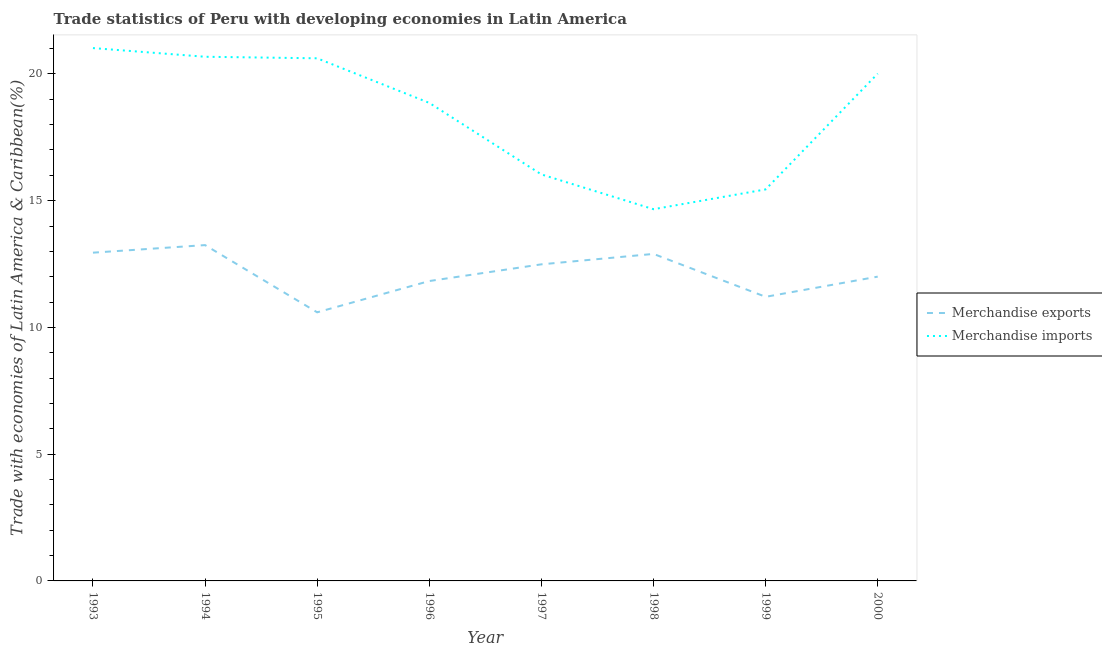Is the number of lines equal to the number of legend labels?
Provide a short and direct response. Yes. What is the merchandise imports in 2000?
Offer a terse response. 20.01. Across all years, what is the maximum merchandise imports?
Your response must be concise. 21.02. Across all years, what is the minimum merchandise imports?
Your response must be concise. 14.66. In which year was the merchandise imports maximum?
Ensure brevity in your answer.  1993. In which year was the merchandise exports minimum?
Give a very brief answer. 1995. What is the total merchandise exports in the graph?
Give a very brief answer. 97.23. What is the difference between the merchandise exports in 1996 and that in 1998?
Provide a short and direct response. -1.07. What is the difference between the merchandise imports in 1997 and the merchandise exports in 1994?
Your answer should be very brief. 2.79. What is the average merchandise imports per year?
Give a very brief answer. 18.42. In the year 1995, what is the difference between the merchandise imports and merchandise exports?
Make the answer very short. 10.02. What is the ratio of the merchandise exports in 1993 to that in 1998?
Provide a succinct answer. 1. Is the merchandise exports in 1997 less than that in 1999?
Your answer should be compact. No. Is the difference between the merchandise exports in 1994 and 1998 greater than the difference between the merchandise imports in 1994 and 1998?
Give a very brief answer. No. What is the difference between the highest and the second highest merchandise imports?
Provide a succinct answer. 0.34. What is the difference between the highest and the lowest merchandise imports?
Your answer should be very brief. 6.36. Is the sum of the merchandise imports in 1995 and 1999 greater than the maximum merchandise exports across all years?
Offer a very short reply. Yes. Does the merchandise exports monotonically increase over the years?
Your answer should be compact. No. Is the merchandise imports strictly greater than the merchandise exports over the years?
Ensure brevity in your answer.  Yes. How many lines are there?
Ensure brevity in your answer.  2. How many years are there in the graph?
Your answer should be compact. 8. What is the difference between two consecutive major ticks on the Y-axis?
Provide a succinct answer. 5. Are the values on the major ticks of Y-axis written in scientific E-notation?
Keep it short and to the point. No. Does the graph contain any zero values?
Give a very brief answer. No. Where does the legend appear in the graph?
Provide a short and direct response. Center right. How many legend labels are there?
Your response must be concise. 2. How are the legend labels stacked?
Your response must be concise. Vertical. What is the title of the graph?
Make the answer very short. Trade statistics of Peru with developing economies in Latin America. Does "Canada" appear as one of the legend labels in the graph?
Offer a very short reply. No. What is the label or title of the Y-axis?
Ensure brevity in your answer.  Trade with economies of Latin America & Caribbean(%). What is the Trade with economies of Latin America & Caribbean(%) of Merchandise exports in 1993?
Offer a very short reply. 12.95. What is the Trade with economies of Latin America & Caribbean(%) of Merchandise imports in 1993?
Give a very brief answer. 21.02. What is the Trade with economies of Latin America & Caribbean(%) in Merchandise exports in 1994?
Provide a succinct answer. 13.25. What is the Trade with economies of Latin America & Caribbean(%) of Merchandise imports in 1994?
Your answer should be very brief. 20.68. What is the Trade with economies of Latin America & Caribbean(%) of Merchandise exports in 1995?
Your answer should be very brief. 10.6. What is the Trade with economies of Latin America & Caribbean(%) in Merchandise imports in 1995?
Provide a succinct answer. 20.62. What is the Trade with economies of Latin America & Caribbean(%) of Merchandise exports in 1996?
Give a very brief answer. 11.83. What is the Trade with economies of Latin America & Caribbean(%) of Merchandise imports in 1996?
Ensure brevity in your answer.  18.86. What is the Trade with economies of Latin America & Caribbean(%) of Merchandise exports in 1997?
Keep it short and to the point. 12.49. What is the Trade with economies of Latin America & Caribbean(%) of Merchandise imports in 1997?
Your answer should be very brief. 16.04. What is the Trade with economies of Latin America & Caribbean(%) of Merchandise exports in 1998?
Your answer should be very brief. 12.9. What is the Trade with economies of Latin America & Caribbean(%) of Merchandise imports in 1998?
Ensure brevity in your answer.  14.66. What is the Trade with economies of Latin America & Caribbean(%) of Merchandise exports in 1999?
Your response must be concise. 11.21. What is the Trade with economies of Latin America & Caribbean(%) in Merchandise imports in 1999?
Your response must be concise. 15.45. What is the Trade with economies of Latin America & Caribbean(%) of Merchandise exports in 2000?
Offer a very short reply. 12. What is the Trade with economies of Latin America & Caribbean(%) of Merchandise imports in 2000?
Your response must be concise. 20.01. Across all years, what is the maximum Trade with economies of Latin America & Caribbean(%) of Merchandise exports?
Give a very brief answer. 13.25. Across all years, what is the maximum Trade with economies of Latin America & Caribbean(%) of Merchandise imports?
Provide a succinct answer. 21.02. Across all years, what is the minimum Trade with economies of Latin America & Caribbean(%) in Merchandise exports?
Ensure brevity in your answer.  10.6. Across all years, what is the minimum Trade with economies of Latin America & Caribbean(%) in Merchandise imports?
Give a very brief answer. 14.66. What is the total Trade with economies of Latin America & Caribbean(%) of Merchandise exports in the graph?
Make the answer very short. 97.23. What is the total Trade with economies of Latin America & Caribbean(%) in Merchandise imports in the graph?
Your answer should be very brief. 147.33. What is the difference between the Trade with economies of Latin America & Caribbean(%) in Merchandise exports in 1993 and that in 1994?
Your answer should be compact. -0.3. What is the difference between the Trade with economies of Latin America & Caribbean(%) of Merchandise imports in 1993 and that in 1994?
Offer a terse response. 0.34. What is the difference between the Trade with economies of Latin America & Caribbean(%) in Merchandise exports in 1993 and that in 1995?
Your answer should be very brief. 2.35. What is the difference between the Trade with economies of Latin America & Caribbean(%) in Merchandise imports in 1993 and that in 1995?
Make the answer very short. 0.4. What is the difference between the Trade with economies of Latin America & Caribbean(%) of Merchandise exports in 1993 and that in 1996?
Your answer should be compact. 1.12. What is the difference between the Trade with economies of Latin America & Caribbean(%) in Merchandise imports in 1993 and that in 1996?
Ensure brevity in your answer.  2.16. What is the difference between the Trade with economies of Latin America & Caribbean(%) in Merchandise exports in 1993 and that in 1997?
Ensure brevity in your answer.  0.46. What is the difference between the Trade with economies of Latin America & Caribbean(%) in Merchandise imports in 1993 and that in 1997?
Offer a terse response. 4.98. What is the difference between the Trade with economies of Latin America & Caribbean(%) in Merchandise exports in 1993 and that in 1998?
Offer a terse response. 0.05. What is the difference between the Trade with economies of Latin America & Caribbean(%) in Merchandise imports in 1993 and that in 1998?
Offer a very short reply. 6.36. What is the difference between the Trade with economies of Latin America & Caribbean(%) in Merchandise exports in 1993 and that in 1999?
Provide a succinct answer. 1.74. What is the difference between the Trade with economies of Latin America & Caribbean(%) of Merchandise imports in 1993 and that in 1999?
Ensure brevity in your answer.  5.58. What is the difference between the Trade with economies of Latin America & Caribbean(%) in Merchandise exports in 1993 and that in 2000?
Your answer should be very brief. 0.95. What is the difference between the Trade with economies of Latin America & Caribbean(%) in Merchandise exports in 1994 and that in 1995?
Your answer should be very brief. 2.65. What is the difference between the Trade with economies of Latin America & Caribbean(%) in Merchandise imports in 1994 and that in 1995?
Keep it short and to the point. 0.06. What is the difference between the Trade with economies of Latin America & Caribbean(%) of Merchandise exports in 1994 and that in 1996?
Your answer should be compact. 1.42. What is the difference between the Trade with economies of Latin America & Caribbean(%) of Merchandise imports in 1994 and that in 1996?
Your response must be concise. 1.82. What is the difference between the Trade with economies of Latin America & Caribbean(%) of Merchandise exports in 1994 and that in 1997?
Your answer should be very brief. 0.76. What is the difference between the Trade with economies of Latin America & Caribbean(%) in Merchandise imports in 1994 and that in 1997?
Offer a terse response. 4.64. What is the difference between the Trade with economies of Latin America & Caribbean(%) of Merchandise exports in 1994 and that in 1998?
Provide a succinct answer. 0.35. What is the difference between the Trade with economies of Latin America & Caribbean(%) in Merchandise imports in 1994 and that in 1998?
Your answer should be compact. 6.01. What is the difference between the Trade with economies of Latin America & Caribbean(%) of Merchandise exports in 1994 and that in 1999?
Keep it short and to the point. 2.04. What is the difference between the Trade with economies of Latin America & Caribbean(%) of Merchandise imports in 1994 and that in 1999?
Your answer should be compact. 5.23. What is the difference between the Trade with economies of Latin America & Caribbean(%) in Merchandise exports in 1994 and that in 2000?
Keep it short and to the point. 1.24. What is the difference between the Trade with economies of Latin America & Caribbean(%) of Merchandise imports in 1994 and that in 2000?
Offer a terse response. 0.67. What is the difference between the Trade with economies of Latin America & Caribbean(%) in Merchandise exports in 1995 and that in 1996?
Your answer should be very brief. -1.23. What is the difference between the Trade with economies of Latin America & Caribbean(%) of Merchandise imports in 1995 and that in 1996?
Ensure brevity in your answer.  1.76. What is the difference between the Trade with economies of Latin America & Caribbean(%) of Merchandise exports in 1995 and that in 1997?
Your answer should be compact. -1.89. What is the difference between the Trade with economies of Latin America & Caribbean(%) in Merchandise imports in 1995 and that in 1997?
Provide a succinct answer. 4.58. What is the difference between the Trade with economies of Latin America & Caribbean(%) of Merchandise exports in 1995 and that in 1998?
Provide a succinct answer. -2.3. What is the difference between the Trade with economies of Latin America & Caribbean(%) of Merchandise imports in 1995 and that in 1998?
Provide a succinct answer. 5.95. What is the difference between the Trade with economies of Latin America & Caribbean(%) of Merchandise exports in 1995 and that in 1999?
Make the answer very short. -0.61. What is the difference between the Trade with economies of Latin America & Caribbean(%) of Merchandise imports in 1995 and that in 1999?
Keep it short and to the point. 5.17. What is the difference between the Trade with economies of Latin America & Caribbean(%) of Merchandise exports in 1995 and that in 2000?
Ensure brevity in your answer.  -1.41. What is the difference between the Trade with economies of Latin America & Caribbean(%) in Merchandise imports in 1995 and that in 2000?
Ensure brevity in your answer.  0.6. What is the difference between the Trade with economies of Latin America & Caribbean(%) of Merchandise exports in 1996 and that in 1997?
Keep it short and to the point. -0.66. What is the difference between the Trade with economies of Latin America & Caribbean(%) in Merchandise imports in 1996 and that in 1997?
Your answer should be compact. 2.82. What is the difference between the Trade with economies of Latin America & Caribbean(%) of Merchandise exports in 1996 and that in 1998?
Your answer should be very brief. -1.07. What is the difference between the Trade with economies of Latin America & Caribbean(%) in Merchandise imports in 1996 and that in 1998?
Offer a very short reply. 4.19. What is the difference between the Trade with economies of Latin America & Caribbean(%) of Merchandise exports in 1996 and that in 1999?
Ensure brevity in your answer.  0.62. What is the difference between the Trade with economies of Latin America & Caribbean(%) in Merchandise imports in 1996 and that in 1999?
Ensure brevity in your answer.  3.41. What is the difference between the Trade with economies of Latin America & Caribbean(%) of Merchandise exports in 1996 and that in 2000?
Provide a succinct answer. -0.17. What is the difference between the Trade with economies of Latin America & Caribbean(%) in Merchandise imports in 1996 and that in 2000?
Provide a succinct answer. -1.15. What is the difference between the Trade with economies of Latin America & Caribbean(%) in Merchandise exports in 1997 and that in 1998?
Your response must be concise. -0.41. What is the difference between the Trade with economies of Latin America & Caribbean(%) in Merchandise imports in 1997 and that in 1998?
Your answer should be compact. 1.37. What is the difference between the Trade with economies of Latin America & Caribbean(%) in Merchandise exports in 1997 and that in 1999?
Your response must be concise. 1.28. What is the difference between the Trade with economies of Latin America & Caribbean(%) of Merchandise imports in 1997 and that in 1999?
Your answer should be compact. 0.59. What is the difference between the Trade with economies of Latin America & Caribbean(%) in Merchandise exports in 1997 and that in 2000?
Your answer should be very brief. 0.49. What is the difference between the Trade with economies of Latin America & Caribbean(%) in Merchandise imports in 1997 and that in 2000?
Give a very brief answer. -3.98. What is the difference between the Trade with economies of Latin America & Caribbean(%) in Merchandise exports in 1998 and that in 1999?
Your response must be concise. 1.69. What is the difference between the Trade with economies of Latin America & Caribbean(%) of Merchandise imports in 1998 and that in 1999?
Your response must be concise. -0.78. What is the difference between the Trade with economies of Latin America & Caribbean(%) of Merchandise exports in 1998 and that in 2000?
Keep it short and to the point. 0.9. What is the difference between the Trade with economies of Latin America & Caribbean(%) of Merchandise imports in 1998 and that in 2000?
Provide a short and direct response. -5.35. What is the difference between the Trade with economies of Latin America & Caribbean(%) in Merchandise exports in 1999 and that in 2000?
Your answer should be very brief. -0.8. What is the difference between the Trade with economies of Latin America & Caribbean(%) of Merchandise imports in 1999 and that in 2000?
Your response must be concise. -4.57. What is the difference between the Trade with economies of Latin America & Caribbean(%) of Merchandise exports in 1993 and the Trade with economies of Latin America & Caribbean(%) of Merchandise imports in 1994?
Provide a short and direct response. -7.73. What is the difference between the Trade with economies of Latin America & Caribbean(%) in Merchandise exports in 1993 and the Trade with economies of Latin America & Caribbean(%) in Merchandise imports in 1995?
Your response must be concise. -7.67. What is the difference between the Trade with economies of Latin America & Caribbean(%) of Merchandise exports in 1993 and the Trade with economies of Latin America & Caribbean(%) of Merchandise imports in 1996?
Make the answer very short. -5.91. What is the difference between the Trade with economies of Latin America & Caribbean(%) in Merchandise exports in 1993 and the Trade with economies of Latin America & Caribbean(%) in Merchandise imports in 1997?
Ensure brevity in your answer.  -3.09. What is the difference between the Trade with economies of Latin America & Caribbean(%) of Merchandise exports in 1993 and the Trade with economies of Latin America & Caribbean(%) of Merchandise imports in 1998?
Ensure brevity in your answer.  -1.71. What is the difference between the Trade with economies of Latin America & Caribbean(%) in Merchandise exports in 1993 and the Trade with economies of Latin America & Caribbean(%) in Merchandise imports in 1999?
Provide a short and direct response. -2.5. What is the difference between the Trade with economies of Latin America & Caribbean(%) in Merchandise exports in 1993 and the Trade with economies of Latin America & Caribbean(%) in Merchandise imports in 2000?
Provide a succinct answer. -7.06. What is the difference between the Trade with economies of Latin America & Caribbean(%) in Merchandise exports in 1994 and the Trade with economies of Latin America & Caribbean(%) in Merchandise imports in 1995?
Ensure brevity in your answer.  -7.37. What is the difference between the Trade with economies of Latin America & Caribbean(%) of Merchandise exports in 1994 and the Trade with economies of Latin America & Caribbean(%) of Merchandise imports in 1996?
Your response must be concise. -5.61. What is the difference between the Trade with economies of Latin America & Caribbean(%) of Merchandise exports in 1994 and the Trade with economies of Latin America & Caribbean(%) of Merchandise imports in 1997?
Your answer should be very brief. -2.79. What is the difference between the Trade with economies of Latin America & Caribbean(%) in Merchandise exports in 1994 and the Trade with economies of Latin America & Caribbean(%) in Merchandise imports in 1998?
Your answer should be very brief. -1.42. What is the difference between the Trade with economies of Latin America & Caribbean(%) in Merchandise exports in 1994 and the Trade with economies of Latin America & Caribbean(%) in Merchandise imports in 1999?
Offer a terse response. -2.2. What is the difference between the Trade with economies of Latin America & Caribbean(%) in Merchandise exports in 1994 and the Trade with economies of Latin America & Caribbean(%) in Merchandise imports in 2000?
Make the answer very short. -6.76. What is the difference between the Trade with economies of Latin America & Caribbean(%) in Merchandise exports in 1995 and the Trade with economies of Latin America & Caribbean(%) in Merchandise imports in 1996?
Keep it short and to the point. -8.26. What is the difference between the Trade with economies of Latin America & Caribbean(%) of Merchandise exports in 1995 and the Trade with economies of Latin America & Caribbean(%) of Merchandise imports in 1997?
Make the answer very short. -5.44. What is the difference between the Trade with economies of Latin America & Caribbean(%) in Merchandise exports in 1995 and the Trade with economies of Latin America & Caribbean(%) in Merchandise imports in 1998?
Your response must be concise. -4.07. What is the difference between the Trade with economies of Latin America & Caribbean(%) in Merchandise exports in 1995 and the Trade with economies of Latin America & Caribbean(%) in Merchandise imports in 1999?
Provide a succinct answer. -4.85. What is the difference between the Trade with economies of Latin America & Caribbean(%) in Merchandise exports in 1995 and the Trade with economies of Latin America & Caribbean(%) in Merchandise imports in 2000?
Give a very brief answer. -9.42. What is the difference between the Trade with economies of Latin America & Caribbean(%) of Merchandise exports in 1996 and the Trade with economies of Latin America & Caribbean(%) of Merchandise imports in 1997?
Give a very brief answer. -4.21. What is the difference between the Trade with economies of Latin America & Caribbean(%) in Merchandise exports in 1996 and the Trade with economies of Latin America & Caribbean(%) in Merchandise imports in 1998?
Provide a succinct answer. -2.83. What is the difference between the Trade with economies of Latin America & Caribbean(%) of Merchandise exports in 1996 and the Trade with economies of Latin America & Caribbean(%) of Merchandise imports in 1999?
Ensure brevity in your answer.  -3.62. What is the difference between the Trade with economies of Latin America & Caribbean(%) of Merchandise exports in 1996 and the Trade with economies of Latin America & Caribbean(%) of Merchandise imports in 2000?
Ensure brevity in your answer.  -8.18. What is the difference between the Trade with economies of Latin America & Caribbean(%) of Merchandise exports in 1997 and the Trade with economies of Latin America & Caribbean(%) of Merchandise imports in 1998?
Your answer should be very brief. -2.17. What is the difference between the Trade with economies of Latin America & Caribbean(%) of Merchandise exports in 1997 and the Trade with economies of Latin America & Caribbean(%) of Merchandise imports in 1999?
Keep it short and to the point. -2.96. What is the difference between the Trade with economies of Latin America & Caribbean(%) of Merchandise exports in 1997 and the Trade with economies of Latin America & Caribbean(%) of Merchandise imports in 2000?
Give a very brief answer. -7.52. What is the difference between the Trade with economies of Latin America & Caribbean(%) in Merchandise exports in 1998 and the Trade with economies of Latin America & Caribbean(%) in Merchandise imports in 1999?
Give a very brief answer. -2.55. What is the difference between the Trade with economies of Latin America & Caribbean(%) in Merchandise exports in 1998 and the Trade with economies of Latin America & Caribbean(%) in Merchandise imports in 2000?
Provide a short and direct response. -7.11. What is the difference between the Trade with economies of Latin America & Caribbean(%) of Merchandise exports in 1999 and the Trade with economies of Latin America & Caribbean(%) of Merchandise imports in 2000?
Offer a terse response. -8.81. What is the average Trade with economies of Latin America & Caribbean(%) in Merchandise exports per year?
Your answer should be very brief. 12.15. What is the average Trade with economies of Latin America & Caribbean(%) of Merchandise imports per year?
Your answer should be compact. 18.42. In the year 1993, what is the difference between the Trade with economies of Latin America & Caribbean(%) in Merchandise exports and Trade with economies of Latin America & Caribbean(%) in Merchandise imports?
Your answer should be compact. -8.07. In the year 1994, what is the difference between the Trade with economies of Latin America & Caribbean(%) in Merchandise exports and Trade with economies of Latin America & Caribbean(%) in Merchandise imports?
Your response must be concise. -7.43. In the year 1995, what is the difference between the Trade with economies of Latin America & Caribbean(%) in Merchandise exports and Trade with economies of Latin America & Caribbean(%) in Merchandise imports?
Give a very brief answer. -10.02. In the year 1996, what is the difference between the Trade with economies of Latin America & Caribbean(%) of Merchandise exports and Trade with economies of Latin America & Caribbean(%) of Merchandise imports?
Offer a terse response. -7.03. In the year 1997, what is the difference between the Trade with economies of Latin America & Caribbean(%) in Merchandise exports and Trade with economies of Latin America & Caribbean(%) in Merchandise imports?
Provide a short and direct response. -3.55. In the year 1998, what is the difference between the Trade with economies of Latin America & Caribbean(%) of Merchandise exports and Trade with economies of Latin America & Caribbean(%) of Merchandise imports?
Your response must be concise. -1.76. In the year 1999, what is the difference between the Trade with economies of Latin America & Caribbean(%) of Merchandise exports and Trade with economies of Latin America & Caribbean(%) of Merchandise imports?
Give a very brief answer. -4.24. In the year 2000, what is the difference between the Trade with economies of Latin America & Caribbean(%) of Merchandise exports and Trade with economies of Latin America & Caribbean(%) of Merchandise imports?
Ensure brevity in your answer.  -8.01. What is the ratio of the Trade with economies of Latin America & Caribbean(%) of Merchandise exports in 1993 to that in 1994?
Give a very brief answer. 0.98. What is the ratio of the Trade with economies of Latin America & Caribbean(%) of Merchandise imports in 1993 to that in 1994?
Provide a succinct answer. 1.02. What is the ratio of the Trade with economies of Latin America & Caribbean(%) in Merchandise exports in 1993 to that in 1995?
Your answer should be compact. 1.22. What is the ratio of the Trade with economies of Latin America & Caribbean(%) in Merchandise imports in 1993 to that in 1995?
Keep it short and to the point. 1.02. What is the ratio of the Trade with economies of Latin America & Caribbean(%) in Merchandise exports in 1993 to that in 1996?
Your answer should be compact. 1.09. What is the ratio of the Trade with economies of Latin America & Caribbean(%) of Merchandise imports in 1993 to that in 1996?
Provide a succinct answer. 1.11. What is the ratio of the Trade with economies of Latin America & Caribbean(%) in Merchandise exports in 1993 to that in 1997?
Your answer should be compact. 1.04. What is the ratio of the Trade with economies of Latin America & Caribbean(%) of Merchandise imports in 1993 to that in 1997?
Offer a very short reply. 1.31. What is the ratio of the Trade with economies of Latin America & Caribbean(%) of Merchandise imports in 1993 to that in 1998?
Your response must be concise. 1.43. What is the ratio of the Trade with economies of Latin America & Caribbean(%) of Merchandise exports in 1993 to that in 1999?
Your answer should be very brief. 1.16. What is the ratio of the Trade with economies of Latin America & Caribbean(%) in Merchandise imports in 1993 to that in 1999?
Give a very brief answer. 1.36. What is the ratio of the Trade with economies of Latin America & Caribbean(%) of Merchandise exports in 1993 to that in 2000?
Your response must be concise. 1.08. What is the ratio of the Trade with economies of Latin America & Caribbean(%) in Merchandise imports in 1993 to that in 2000?
Keep it short and to the point. 1.05. What is the ratio of the Trade with economies of Latin America & Caribbean(%) in Merchandise exports in 1994 to that in 1995?
Your answer should be compact. 1.25. What is the ratio of the Trade with economies of Latin America & Caribbean(%) in Merchandise imports in 1994 to that in 1995?
Offer a very short reply. 1. What is the ratio of the Trade with economies of Latin America & Caribbean(%) in Merchandise exports in 1994 to that in 1996?
Make the answer very short. 1.12. What is the ratio of the Trade with economies of Latin America & Caribbean(%) in Merchandise imports in 1994 to that in 1996?
Your answer should be very brief. 1.1. What is the ratio of the Trade with economies of Latin America & Caribbean(%) in Merchandise exports in 1994 to that in 1997?
Provide a short and direct response. 1.06. What is the ratio of the Trade with economies of Latin America & Caribbean(%) in Merchandise imports in 1994 to that in 1997?
Keep it short and to the point. 1.29. What is the ratio of the Trade with economies of Latin America & Caribbean(%) in Merchandise imports in 1994 to that in 1998?
Your response must be concise. 1.41. What is the ratio of the Trade with economies of Latin America & Caribbean(%) of Merchandise exports in 1994 to that in 1999?
Your answer should be compact. 1.18. What is the ratio of the Trade with economies of Latin America & Caribbean(%) in Merchandise imports in 1994 to that in 1999?
Make the answer very short. 1.34. What is the ratio of the Trade with economies of Latin America & Caribbean(%) of Merchandise exports in 1994 to that in 2000?
Make the answer very short. 1.1. What is the ratio of the Trade with economies of Latin America & Caribbean(%) in Merchandise imports in 1994 to that in 2000?
Ensure brevity in your answer.  1.03. What is the ratio of the Trade with economies of Latin America & Caribbean(%) of Merchandise exports in 1995 to that in 1996?
Offer a very short reply. 0.9. What is the ratio of the Trade with economies of Latin America & Caribbean(%) of Merchandise imports in 1995 to that in 1996?
Offer a very short reply. 1.09. What is the ratio of the Trade with economies of Latin America & Caribbean(%) of Merchandise exports in 1995 to that in 1997?
Your answer should be compact. 0.85. What is the ratio of the Trade with economies of Latin America & Caribbean(%) in Merchandise imports in 1995 to that in 1997?
Your answer should be very brief. 1.29. What is the ratio of the Trade with economies of Latin America & Caribbean(%) of Merchandise exports in 1995 to that in 1998?
Your answer should be compact. 0.82. What is the ratio of the Trade with economies of Latin America & Caribbean(%) of Merchandise imports in 1995 to that in 1998?
Provide a short and direct response. 1.41. What is the ratio of the Trade with economies of Latin America & Caribbean(%) in Merchandise exports in 1995 to that in 1999?
Give a very brief answer. 0.95. What is the ratio of the Trade with economies of Latin America & Caribbean(%) in Merchandise imports in 1995 to that in 1999?
Provide a short and direct response. 1.33. What is the ratio of the Trade with economies of Latin America & Caribbean(%) in Merchandise exports in 1995 to that in 2000?
Your response must be concise. 0.88. What is the ratio of the Trade with economies of Latin America & Caribbean(%) in Merchandise imports in 1995 to that in 2000?
Ensure brevity in your answer.  1.03. What is the ratio of the Trade with economies of Latin America & Caribbean(%) in Merchandise exports in 1996 to that in 1997?
Offer a very short reply. 0.95. What is the ratio of the Trade with economies of Latin America & Caribbean(%) of Merchandise imports in 1996 to that in 1997?
Provide a short and direct response. 1.18. What is the ratio of the Trade with economies of Latin America & Caribbean(%) in Merchandise exports in 1996 to that in 1998?
Your response must be concise. 0.92. What is the ratio of the Trade with economies of Latin America & Caribbean(%) in Merchandise imports in 1996 to that in 1998?
Make the answer very short. 1.29. What is the ratio of the Trade with economies of Latin America & Caribbean(%) in Merchandise exports in 1996 to that in 1999?
Your answer should be compact. 1.06. What is the ratio of the Trade with economies of Latin America & Caribbean(%) of Merchandise imports in 1996 to that in 1999?
Ensure brevity in your answer.  1.22. What is the ratio of the Trade with economies of Latin America & Caribbean(%) of Merchandise exports in 1996 to that in 2000?
Ensure brevity in your answer.  0.99. What is the ratio of the Trade with economies of Latin America & Caribbean(%) in Merchandise imports in 1996 to that in 2000?
Your response must be concise. 0.94. What is the ratio of the Trade with economies of Latin America & Caribbean(%) of Merchandise exports in 1997 to that in 1998?
Your answer should be compact. 0.97. What is the ratio of the Trade with economies of Latin America & Caribbean(%) in Merchandise imports in 1997 to that in 1998?
Provide a short and direct response. 1.09. What is the ratio of the Trade with economies of Latin America & Caribbean(%) in Merchandise exports in 1997 to that in 1999?
Your response must be concise. 1.11. What is the ratio of the Trade with economies of Latin America & Caribbean(%) of Merchandise imports in 1997 to that in 1999?
Give a very brief answer. 1.04. What is the ratio of the Trade with economies of Latin America & Caribbean(%) of Merchandise exports in 1997 to that in 2000?
Keep it short and to the point. 1.04. What is the ratio of the Trade with economies of Latin America & Caribbean(%) of Merchandise imports in 1997 to that in 2000?
Provide a succinct answer. 0.8. What is the ratio of the Trade with economies of Latin America & Caribbean(%) of Merchandise exports in 1998 to that in 1999?
Your answer should be very brief. 1.15. What is the ratio of the Trade with economies of Latin America & Caribbean(%) in Merchandise imports in 1998 to that in 1999?
Give a very brief answer. 0.95. What is the ratio of the Trade with economies of Latin America & Caribbean(%) of Merchandise exports in 1998 to that in 2000?
Provide a short and direct response. 1.07. What is the ratio of the Trade with economies of Latin America & Caribbean(%) in Merchandise imports in 1998 to that in 2000?
Offer a terse response. 0.73. What is the ratio of the Trade with economies of Latin America & Caribbean(%) of Merchandise exports in 1999 to that in 2000?
Keep it short and to the point. 0.93. What is the ratio of the Trade with economies of Latin America & Caribbean(%) in Merchandise imports in 1999 to that in 2000?
Make the answer very short. 0.77. What is the difference between the highest and the second highest Trade with economies of Latin America & Caribbean(%) of Merchandise exports?
Offer a very short reply. 0.3. What is the difference between the highest and the second highest Trade with economies of Latin America & Caribbean(%) in Merchandise imports?
Keep it short and to the point. 0.34. What is the difference between the highest and the lowest Trade with economies of Latin America & Caribbean(%) of Merchandise exports?
Your answer should be compact. 2.65. What is the difference between the highest and the lowest Trade with economies of Latin America & Caribbean(%) of Merchandise imports?
Make the answer very short. 6.36. 